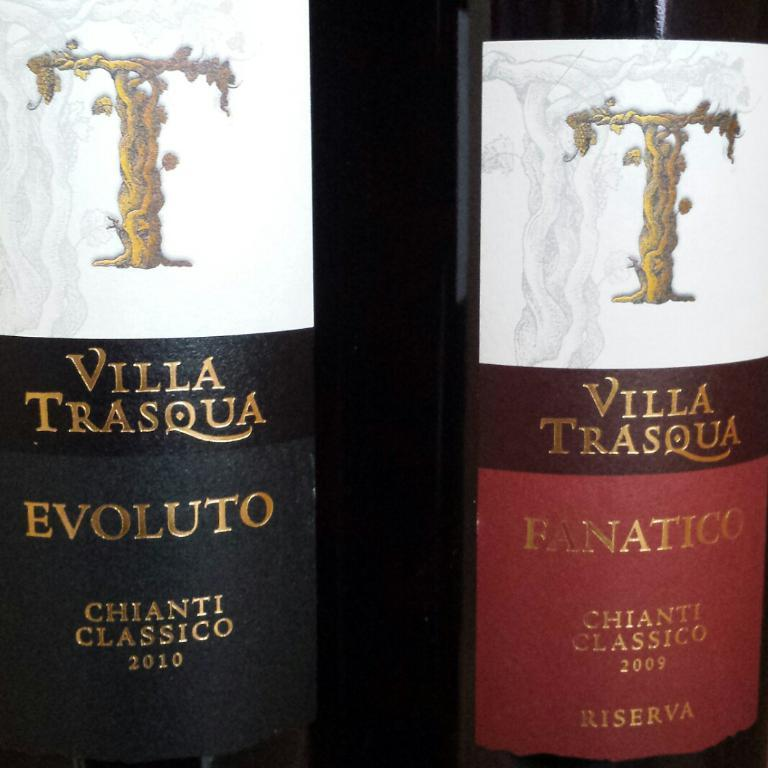Provide a one-sentence caption for the provided image. Two bottles of Villa Trasqua wine stand side by side each other. 